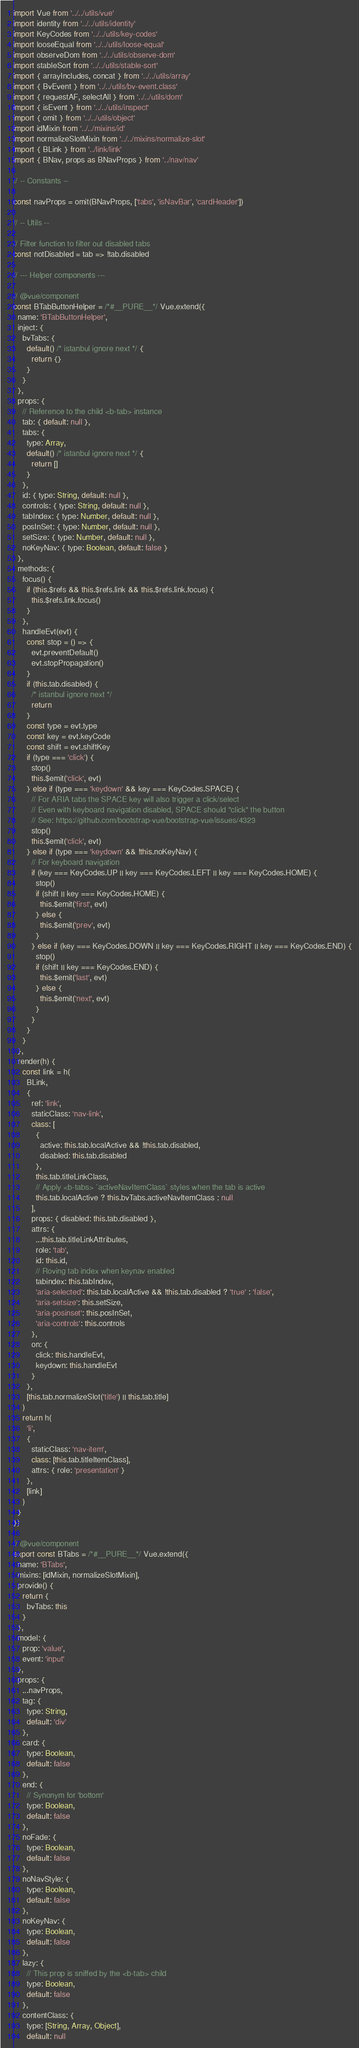Convert code to text. <code><loc_0><loc_0><loc_500><loc_500><_JavaScript_>import Vue from '../../utils/vue'
import identity from '../../utils/identity'
import KeyCodes from '../../utils/key-codes'
import looseEqual from '../../utils/loose-equal'
import observeDom from '../../utils/observe-dom'
import stableSort from '../../utils/stable-sort'
import { arrayIncludes, concat } from '../../utils/array'
import { BvEvent } from '../../utils/bv-event.class'
import { requestAF, selectAll } from '../../utils/dom'
import { isEvent } from '../../utils/inspect'
import { omit } from '../../utils/object'
import idMixin from '../../mixins/id'
import normalizeSlotMixin from '../../mixins/normalize-slot'
import { BLink } from '../link/link'
import { BNav, props as BNavProps } from '../nav/nav'

// -- Constants --

const navProps = omit(BNavProps, ['tabs', 'isNavBar', 'cardHeader'])

// -- Utils --

// Filter function to filter out disabled tabs
const notDisabled = tab => !tab.disabled

// --- Helper components ---

// @vue/component
const BTabButtonHelper = /*#__PURE__*/ Vue.extend({
  name: 'BTabButtonHelper',
  inject: {
    bvTabs: {
      default() /* istanbul ignore next */ {
        return {}
      }
    }
  },
  props: {
    // Reference to the child <b-tab> instance
    tab: { default: null },
    tabs: {
      type: Array,
      default() /* istanbul ignore next */ {
        return []
      }
    },
    id: { type: String, default: null },
    controls: { type: String, default: null },
    tabIndex: { type: Number, default: null },
    posInSet: { type: Number, default: null },
    setSize: { type: Number, default: null },
    noKeyNav: { type: Boolean, default: false }
  },
  methods: {
    focus() {
      if (this.$refs && this.$refs.link && this.$refs.link.focus) {
        this.$refs.link.focus()
      }
    },
    handleEvt(evt) {
      const stop = () => {
        evt.preventDefault()
        evt.stopPropagation()
      }
      if (this.tab.disabled) {
        /* istanbul ignore next */
        return
      }
      const type = evt.type
      const key = evt.keyCode
      const shift = evt.shiftKey
      if (type === 'click') {
        stop()
        this.$emit('click', evt)
      } else if (type === 'keydown' && key === KeyCodes.SPACE) {
        // For ARIA tabs the SPACE key will also trigger a click/select
        // Even with keyboard navigation disabled, SPACE should "click" the button
        // See: https://github.com/bootstrap-vue/bootstrap-vue/issues/4323
        stop()
        this.$emit('click', evt)
      } else if (type === 'keydown' && !this.noKeyNav) {
        // For keyboard navigation
        if (key === KeyCodes.UP || key === KeyCodes.LEFT || key === KeyCodes.HOME) {
          stop()
          if (shift || key === KeyCodes.HOME) {
            this.$emit('first', evt)
          } else {
            this.$emit('prev', evt)
          }
        } else if (key === KeyCodes.DOWN || key === KeyCodes.RIGHT || key === KeyCodes.END) {
          stop()
          if (shift || key === KeyCodes.END) {
            this.$emit('last', evt)
          } else {
            this.$emit('next', evt)
          }
        }
      }
    }
  },
  render(h) {
    const link = h(
      BLink,
      {
        ref: 'link',
        staticClass: 'nav-link',
        class: [
          {
            active: this.tab.localActive && !this.tab.disabled,
            disabled: this.tab.disabled
          },
          this.tab.titleLinkClass,
          // Apply <b-tabs> `activeNavItemClass` styles when the tab is active
          this.tab.localActive ? this.bvTabs.activeNavItemClass : null
        ],
        props: { disabled: this.tab.disabled },
        attrs: {
          ...this.tab.titleLinkAttributes,
          role: 'tab',
          id: this.id,
          // Roving tab index when keynav enabled
          tabindex: this.tabIndex,
          'aria-selected': this.tab.localActive && !this.tab.disabled ? 'true' : 'false',
          'aria-setsize': this.setSize,
          'aria-posinset': this.posInSet,
          'aria-controls': this.controls
        },
        on: {
          click: this.handleEvt,
          keydown: this.handleEvt
        }
      },
      [this.tab.normalizeSlot('title') || this.tab.title]
    )
    return h(
      'li',
      {
        staticClass: 'nav-item',
        class: [this.tab.titleItemClass],
        attrs: { role: 'presentation' }
      },
      [link]
    )
  }
})

// @vue/component
export const BTabs = /*#__PURE__*/ Vue.extend({
  name: 'BTabs',
  mixins: [idMixin, normalizeSlotMixin],
  provide() {
    return {
      bvTabs: this
    }
  },
  model: {
    prop: 'value',
    event: 'input'
  },
  props: {
    ...navProps,
    tag: {
      type: String,
      default: 'div'
    },
    card: {
      type: Boolean,
      default: false
    },
    end: {
      // Synonym for 'bottom'
      type: Boolean,
      default: false
    },
    noFade: {
      type: Boolean,
      default: false
    },
    noNavStyle: {
      type: Boolean,
      default: false
    },
    noKeyNav: {
      type: Boolean,
      default: false
    },
    lazy: {
      // This prop is sniffed by the <b-tab> child
      type: Boolean,
      default: false
    },
    contentClass: {
      type: [String, Array, Object],
      default: null</code> 